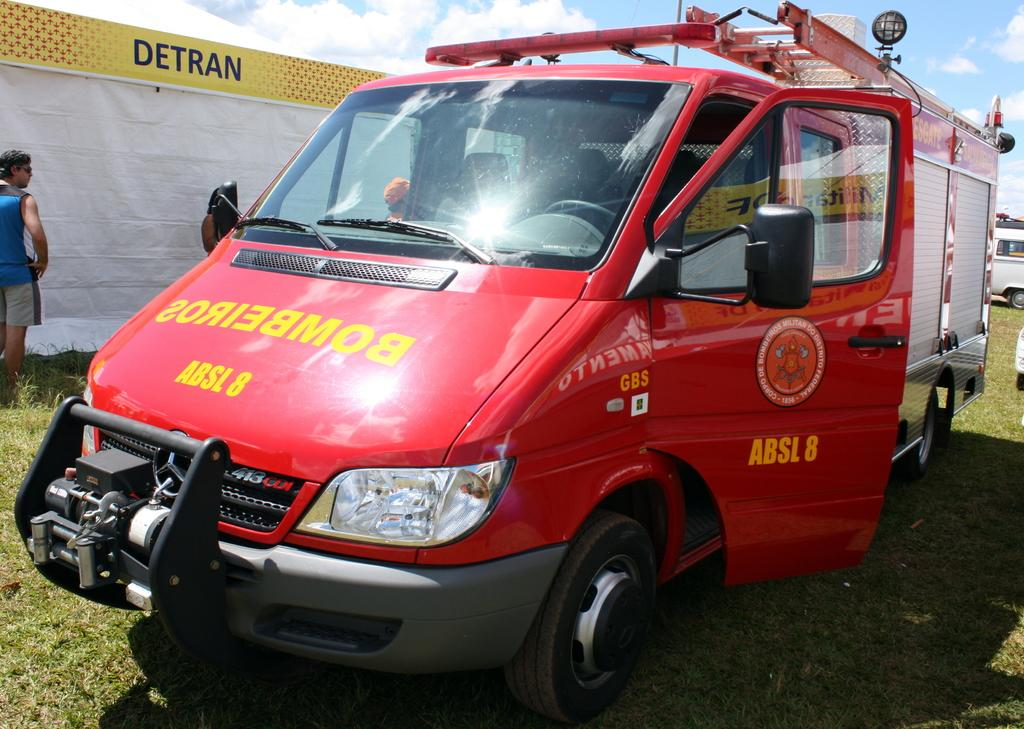<image>
Relay a brief, clear account of the picture shown. A red truck with a mounted ladder on top has an ID of ABSL 8. 